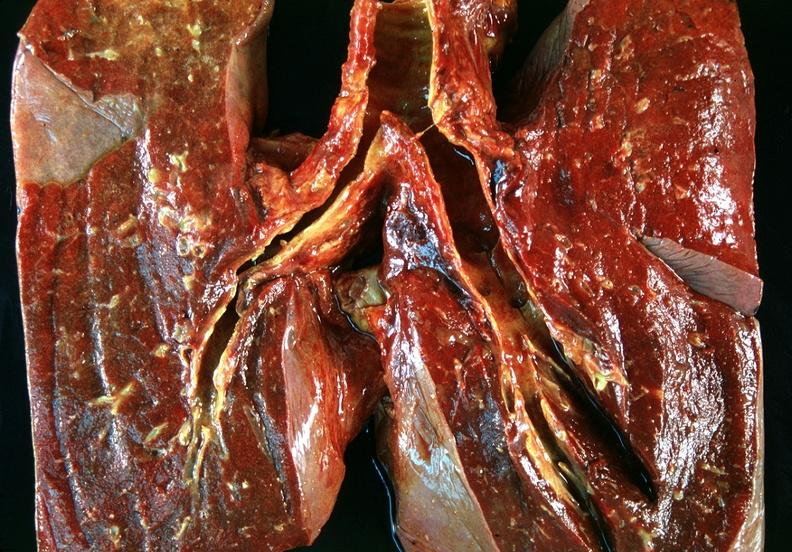does this image show lung, bronchitis and oxygen toxicity with hyaline membranes?
Answer the question using a single word or phrase. Yes 